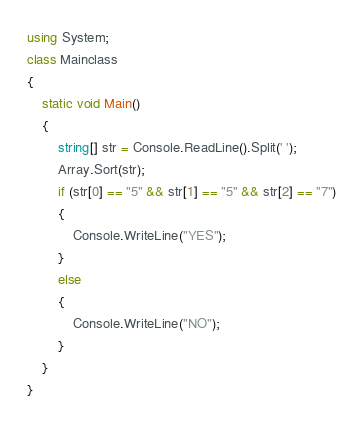Convert code to text. <code><loc_0><loc_0><loc_500><loc_500><_C#_>using System;
class Mainclass
{
    static void Main()
    {
        string[] str = Console.ReadLine().Split(' ');
        Array.Sort(str);
        if (str[0] == "5" && str[1] == "5" && str[2] == "7")
        {
            Console.WriteLine("YES");
        }
        else
        {
            Console.WriteLine("NO");
        }
    }
}</code> 